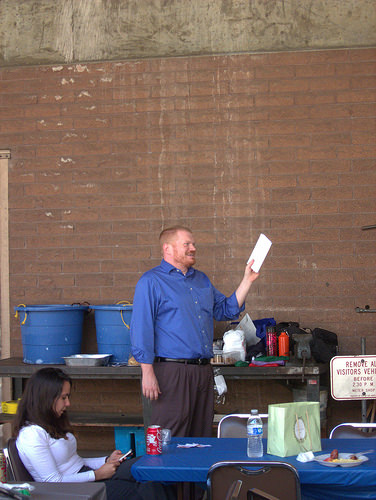<image>
Is the man in the woman? No. The man is not contained within the woman. These objects have a different spatial relationship. 